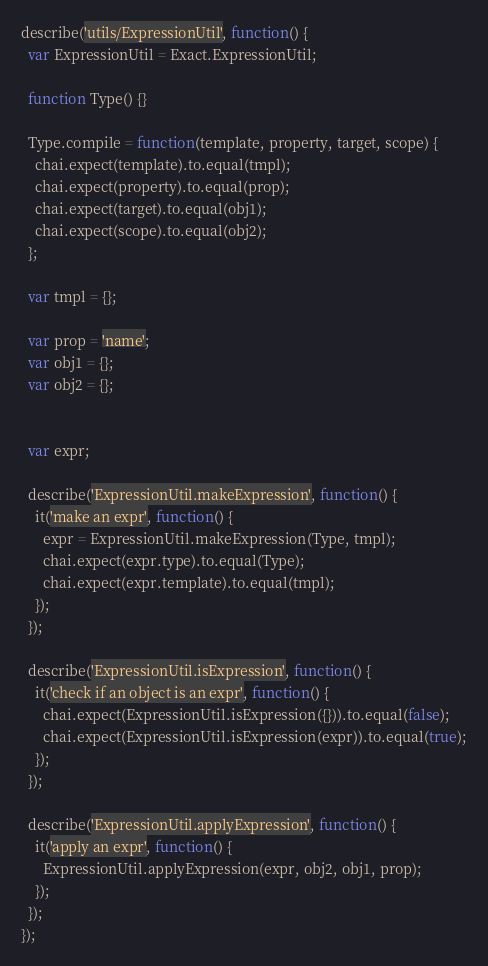Convert code to text. <code><loc_0><loc_0><loc_500><loc_500><_JavaScript_>describe('utils/ExpressionUtil', function() {
  var ExpressionUtil = Exact.ExpressionUtil;

  function Type() {}

  Type.compile = function(template, property, target, scope) {
    chai.expect(template).to.equal(tmpl);
    chai.expect(property).to.equal(prop);
    chai.expect(target).to.equal(obj1);
    chai.expect(scope).to.equal(obj2);
  };

  var tmpl = {};

  var prop = 'name';
  var obj1 = {};
  var obj2 = {};


  var expr;

  describe('ExpressionUtil.makeExpression', function() {
    it('make an expr', function() {
      expr = ExpressionUtil.makeExpression(Type, tmpl);
      chai.expect(expr.type).to.equal(Type);
      chai.expect(expr.template).to.equal(tmpl);
    });
  });

  describe('ExpressionUtil.isExpression', function() {
    it('check if an object is an expr', function() {
      chai.expect(ExpressionUtil.isExpression({})).to.equal(false);
      chai.expect(ExpressionUtil.isExpression(expr)).to.equal(true);
    });
  });

  describe('ExpressionUtil.applyExpression', function() {
    it('apply an expr', function() {
      ExpressionUtil.applyExpression(expr, obj2, obj1, prop);
    });
  });
});
</code> 